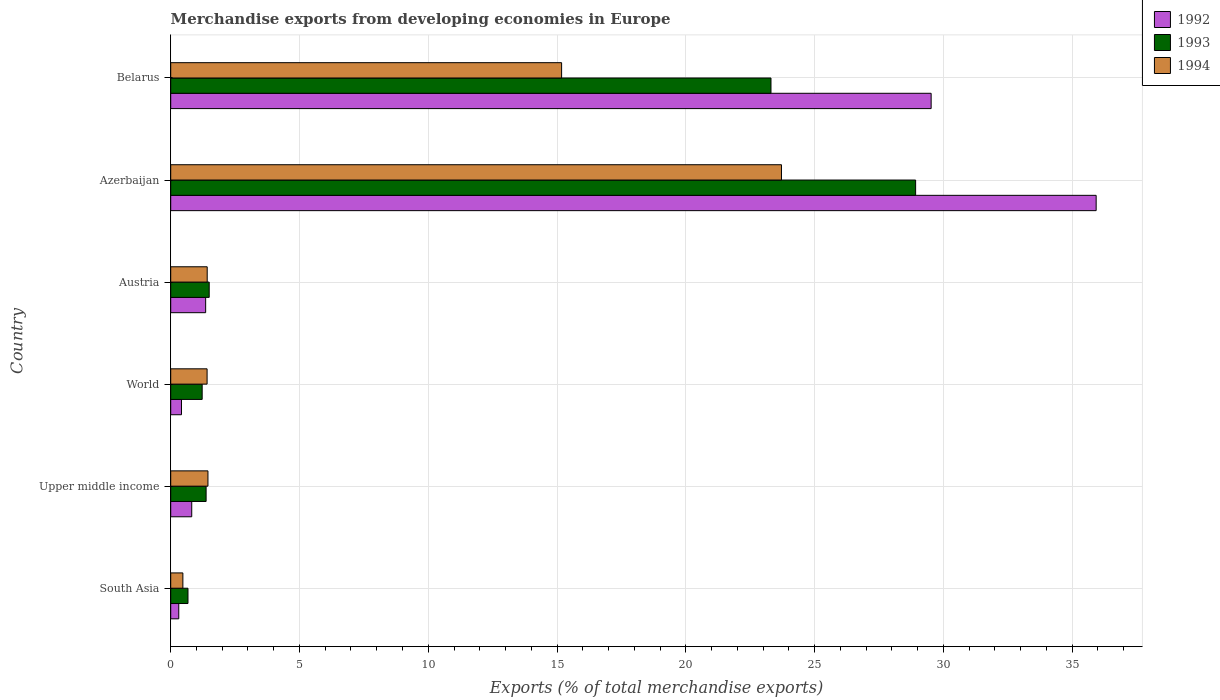How many groups of bars are there?
Keep it short and to the point. 6. Are the number of bars on each tick of the Y-axis equal?
Offer a terse response. Yes. How many bars are there on the 3rd tick from the top?
Offer a very short reply. 3. What is the label of the 4th group of bars from the top?
Provide a short and direct response. World. In how many cases, is the number of bars for a given country not equal to the number of legend labels?
Provide a short and direct response. 0. What is the percentage of total merchandise exports in 1994 in World?
Provide a short and direct response. 1.41. Across all countries, what is the maximum percentage of total merchandise exports in 1994?
Ensure brevity in your answer.  23.72. Across all countries, what is the minimum percentage of total merchandise exports in 1993?
Your answer should be compact. 0.67. In which country was the percentage of total merchandise exports in 1992 maximum?
Offer a very short reply. Azerbaijan. What is the total percentage of total merchandise exports in 1992 in the graph?
Your answer should be compact. 68.37. What is the difference between the percentage of total merchandise exports in 1992 in Azerbaijan and that in Upper middle income?
Provide a short and direct response. 35.12. What is the difference between the percentage of total merchandise exports in 1994 in South Asia and the percentage of total merchandise exports in 1992 in World?
Your answer should be compact. 0.05. What is the average percentage of total merchandise exports in 1993 per country?
Ensure brevity in your answer.  9.5. What is the difference between the percentage of total merchandise exports in 1992 and percentage of total merchandise exports in 1994 in Upper middle income?
Keep it short and to the point. -0.63. In how many countries, is the percentage of total merchandise exports in 1992 greater than 6 %?
Offer a very short reply. 2. What is the ratio of the percentage of total merchandise exports in 1993 in Austria to that in South Asia?
Offer a very short reply. 2.23. Is the percentage of total merchandise exports in 1992 in Azerbaijan less than that in South Asia?
Your answer should be compact. No. What is the difference between the highest and the second highest percentage of total merchandise exports in 1994?
Keep it short and to the point. 8.54. What is the difference between the highest and the lowest percentage of total merchandise exports in 1992?
Provide a short and direct response. 35.62. In how many countries, is the percentage of total merchandise exports in 1993 greater than the average percentage of total merchandise exports in 1993 taken over all countries?
Your answer should be compact. 2. What does the 2nd bar from the top in South Asia represents?
Your answer should be compact. 1993. What does the 1st bar from the bottom in South Asia represents?
Provide a short and direct response. 1992. Is it the case that in every country, the sum of the percentage of total merchandise exports in 1993 and percentage of total merchandise exports in 1994 is greater than the percentage of total merchandise exports in 1992?
Provide a short and direct response. Yes. Are all the bars in the graph horizontal?
Offer a terse response. Yes. How many countries are there in the graph?
Offer a terse response. 6. Does the graph contain any zero values?
Provide a short and direct response. No. Does the graph contain grids?
Offer a very short reply. Yes. How are the legend labels stacked?
Offer a terse response. Vertical. What is the title of the graph?
Make the answer very short. Merchandise exports from developing economies in Europe. Does "2009" appear as one of the legend labels in the graph?
Your response must be concise. No. What is the label or title of the X-axis?
Provide a succinct answer. Exports (% of total merchandise exports). What is the Exports (% of total merchandise exports) in 1992 in South Asia?
Provide a short and direct response. 0.31. What is the Exports (% of total merchandise exports) of 1993 in South Asia?
Ensure brevity in your answer.  0.67. What is the Exports (% of total merchandise exports) in 1994 in South Asia?
Ensure brevity in your answer.  0.47. What is the Exports (% of total merchandise exports) of 1992 in Upper middle income?
Provide a succinct answer. 0.82. What is the Exports (% of total merchandise exports) of 1993 in Upper middle income?
Offer a terse response. 1.37. What is the Exports (% of total merchandise exports) in 1994 in Upper middle income?
Offer a terse response. 1.45. What is the Exports (% of total merchandise exports) in 1992 in World?
Your response must be concise. 0.42. What is the Exports (% of total merchandise exports) of 1993 in World?
Provide a succinct answer. 1.22. What is the Exports (% of total merchandise exports) in 1994 in World?
Make the answer very short. 1.41. What is the Exports (% of total merchandise exports) of 1992 in Austria?
Provide a short and direct response. 1.36. What is the Exports (% of total merchandise exports) of 1993 in Austria?
Provide a succinct answer. 1.49. What is the Exports (% of total merchandise exports) of 1994 in Austria?
Make the answer very short. 1.42. What is the Exports (% of total merchandise exports) in 1992 in Azerbaijan?
Provide a short and direct response. 35.94. What is the Exports (% of total merchandise exports) of 1993 in Azerbaijan?
Provide a short and direct response. 28.93. What is the Exports (% of total merchandise exports) in 1994 in Azerbaijan?
Offer a very short reply. 23.72. What is the Exports (% of total merchandise exports) of 1992 in Belarus?
Provide a succinct answer. 29.53. What is the Exports (% of total merchandise exports) in 1993 in Belarus?
Your answer should be very brief. 23.31. What is the Exports (% of total merchandise exports) in 1994 in Belarus?
Keep it short and to the point. 15.18. Across all countries, what is the maximum Exports (% of total merchandise exports) of 1992?
Provide a short and direct response. 35.94. Across all countries, what is the maximum Exports (% of total merchandise exports) of 1993?
Provide a succinct answer. 28.93. Across all countries, what is the maximum Exports (% of total merchandise exports) in 1994?
Ensure brevity in your answer.  23.72. Across all countries, what is the minimum Exports (% of total merchandise exports) in 1992?
Provide a short and direct response. 0.31. Across all countries, what is the minimum Exports (% of total merchandise exports) of 1993?
Keep it short and to the point. 0.67. Across all countries, what is the minimum Exports (% of total merchandise exports) in 1994?
Provide a short and direct response. 0.47. What is the total Exports (% of total merchandise exports) in 1992 in the graph?
Your response must be concise. 68.37. What is the total Exports (% of total merchandise exports) in 1993 in the graph?
Ensure brevity in your answer.  57. What is the total Exports (% of total merchandise exports) in 1994 in the graph?
Keep it short and to the point. 43.64. What is the difference between the Exports (% of total merchandise exports) of 1992 in South Asia and that in Upper middle income?
Your answer should be compact. -0.5. What is the difference between the Exports (% of total merchandise exports) in 1993 in South Asia and that in Upper middle income?
Your answer should be compact. -0.7. What is the difference between the Exports (% of total merchandise exports) in 1994 in South Asia and that in Upper middle income?
Keep it short and to the point. -0.97. What is the difference between the Exports (% of total merchandise exports) of 1992 in South Asia and that in World?
Keep it short and to the point. -0.11. What is the difference between the Exports (% of total merchandise exports) in 1993 in South Asia and that in World?
Give a very brief answer. -0.55. What is the difference between the Exports (% of total merchandise exports) in 1994 in South Asia and that in World?
Keep it short and to the point. -0.94. What is the difference between the Exports (% of total merchandise exports) in 1992 in South Asia and that in Austria?
Your answer should be compact. -1.04. What is the difference between the Exports (% of total merchandise exports) in 1993 in South Asia and that in Austria?
Your response must be concise. -0.82. What is the difference between the Exports (% of total merchandise exports) in 1994 in South Asia and that in Austria?
Give a very brief answer. -0.94. What is the difference between the Exports (% of total merchandise exports) in 1992 in South Asia and that in Azerbaijan?
Make the answer very short. -35.62. What is the difference between the Exports (% of total merchandise exports) of 1993 in South Asia and that in Azerbaijan?
Provide a succinct answer. -28.26. What is the difference between the Exports (% of total merchandise exports) of 1994 in South Asia and that in Azerbaijan?
Your answer should be very brief. -23.24. What is the difference between the Exports (% of total merchandise exports) of 1992 in South Asia and that in Belarus?
Your answer should be very brief. -29.21. What is the difference between the Exports (% of total merchandise exports) of 1993 in South Asia and that in Belarus?
Your response must be concise. -22.64. What is the difference between the Exports (% of total merchandise exports) of 1994 in South Asia and that in Belarus?
Your answer should be very brief. -14.71. What is the difference between the Exports (% of total merchandise exports) in 1992 in Upper middle income and that in World?
Your answer should be very brief. 0.4. What is the difference between the Exports (% of total merchandise exports) in 1993 in Upper middle income and that in World?
Give a very brief answer. 0.15. What is the difference between the Exports (% of total merchandise exports) in 1994 in Upper middle income and that in World?
Make the answer very short. 0.03. What is the difference between the Exports (% of total merchandise exports) of 1992 in Upper middle income and that in Austria?
Give a very brief answer. -0.54. What is the difference between the Exports (% of total merchandise exports) of 1993 in Upper middle income and that in Austria?
Make the answer very short. -0.12. What is the difference between the Exports (% of total merchandise exports) of 1994 in Upper middle income and that in Austria?
Make the answer very short. 0.03. What is the difference between the Exports (% of total merchandise exports) of 1992 in Upper middle income and that in Azerbaijan?
Offer a terse response. -35.12. What is the difference between the Exports (% of total merchandise exports) in 1993 in Upper middle income and that in Azerbaijan?
Your answer should be very brief. -27.55. What is the difference between the Exports (% of total merchandise exports) in 1994 in Upper middle income and that in Azerbaijan?
Ensure brevity in your answer.  -22.27. What is the difference between the Exports (% of total merchandise exports) in 1992 in Upper middle income and that in Belarus?
Give a very brief answer. -28.71. What is the difference between the Exports (% of total merchandise exports) of 1993 in Upper middle income and that in Belarus?
Give a very brief answer. -21.93. What is the difference between the Exports (% of total merchandise exports) in 1994 in Upper middle income and that in Belarus?
Provide a succinct answer. -13.73. What is the difference between the Exports (% of total merchandise exports) of 1992 in World and that in Austria?
Provide a succinct answer. -0.94. What is the difference between the Exports (% of total merchandise exports) in 1993 in World and that in Austria?
Give a very brief answer. -0.27. What is the difference between the Exports (% of total merchandise exports) of 1994 in World and that in Austria?
Ensure brevity in your answer.  -0. What is the difference between the Exports (% of total merchandise exports) of 1992 in World and that in Azerbaijan?
Your response must be concise. -35.52. What is the difference between the Exports (% of total merchandise exports) of 1993 in World and that in Azerbaijan?
Offer a very short reply. -27.7. What is the difference between the Exports (% of total merchandise exports) in 1994 in World and that in Azerbaijan?
Provide a succinct answer. -22.3. What is the difference between the Exports (% of total merchandise exports) of 1992 in World and that in Belarus?
Your answer should be very brief. -29.11. What is the difference between the Exports (% of total merchandise exports) of 1993 in World and that in Belarus?
Give a very brief answer. -22.09. What is the difference between the Exports (% of total merchandise exports) of 1994 in World and that in Belarus?
Offer a very short reply. -13.77. What is the difference between the Exports (% of total merchandise exports) of 1992 in Austria and that in Azerbaijan?
Your response must be concise. -34.58. What is the difference between the Exports (% of total merchandise exports) in 1993 in Austria and that in Azerbaijan?
Provide a succinct answer. -27.43. What is the difference between the Exports (% of total merchandise exports) in 1994 in Austria and that in Azerbaijan?
Keep it short and to the point. -22.3. What is the difference between the Exports (% of total merchandise exports) in 1992 in Austria and that in Belarus?
Your response must be concise. -28.17. What is the difference between the Exports (% of total merchandise exports) in 1993 in Austria and that in Belarus?
Make the answer very short. -21.81. What is the difference between the Exports (% of total merchandise exports) in 1994 in Austria and that in Belarus?
Provide a short and direct response. -13.76. What is the difference between the Exports (% of total merchandise exports) of 1992 in Azerbaijan and that in Belarus?
Your answer should be very brief. 6.41. What is the difference between the Exports (% of total merchandise exports) of 1993 in Azerbaijan and that in Belarus?
Make the answer very short. 5.62. What is the difference between the Exports (% of total merchandise exports) in 1994 in Azerbaijan and that in Belarus?
Make the answer very short. 8.54. What is the difference between the Exports (% of total merchandise exports) in 1992 in South Asia and the Exports (% of total merchandise exports) in 1993 in Upper middle income?
Keep it short and to the point. -1.06. What is the difference between the Exports (% of total merchandise exports) in 1992 in South Asia and the Exports (% of total merchandise exports) in 1994 in Upper middle income?
Provide a succinct answer. -1.13. What is the difference between the Exports (% of total merchandise exports) of 1993 in South Asia and the Exports (% of total merchandise exports) of 1994 in Upper middle income?
Provide a succinct answer. -0.78. What is the difference between the Exports (% of total merchandise exports) in 1992 in South Asia and the Exports (% of total merchandise exports) in 1993 in World?
Offer a terse response. -0.91. What is the difference between the Exports (% of total merchandise exports) in 1992 in South Asia and the Exports (% of total merchandise exports) in 1994 in World?
Provide a short and direct response. -1.1. What is the difference between the Exports (% of total merchandise exports) of 1993 in South Asia and the Exports (% of total merchandise exports) of 1994 in World?
Provide a succinct answer. -0.74. What is the difference between the Exports (% of total merchandise exports) in 1992 in South Asia and the Exports (% of total merchandise exports) in 1993 in Austria?
Give a very brief answer. -1.18. What is the difference between the Exports (% of total merchandise exports) in 1992 in South Asia and the Exports (% of total merchandise exports) in 1994 in Austria?
Ensure brevity in your answer.  -1.1. What is the difference between the Exports (% of total merchandise exports) of 1993 in South Asia and the Exports (% of total merchandise exports) of 1994 in Austria?
Offer a very short reply. -0.75. What is the difference between the Exports (% of total merchandise exports) in 1992 in South Asia and the Exports (% of total merchandise exports) in 1993 in Azerbaijan?
Keep it short and to the point. -28.61. What is the difference between the Exports (% of total merchandise exports) of 1992 in South Asia and the Exports (% of total merchandise exports) of 1994 in Azerbaijan?
Your answer should be compact. -23.4. What is the difference between the Exports (% of total merchandise exports) in 1993 in South Asia and the Exports (% of total merchandise exports) in 1994 in Azerbaijan?
Your answer should be very brief. -23.05. What is the difference between the Exports (% of total merchandise exports) of 1992 in South Asia and the Exports (% of total merchandise exports) of 1993 in Belarus?
Offer a terse response. -23. What is the difference between the Exports (% of total merchandise exports) of 1992 in South Asia and the Exports (% of total merchandise exports) of 1994 in Belarus?
Ensure brevity in your answer.  -14.87. What is the difference between the Exports (% of total merchandise exports) in 1993 in South Asia and the Exports (% of total merchandise exports) in 1994 in Belarus?
Make the answer very short. -14.51. What is the difference between the Exports (% of total merchandise exports) of 1992 in Upper middle income and the Exports (% of total merchandise exports) of 1993 in World?
Your response must be concise. -0.41. What is the difference between the Exports (% of total merchandise exports) of 1992 in Upper middle income and the Exports (% of total merchandise exports) of 1994 in World?
Offer a terse response. -0.6. What is the difference between the Exports (% of total merchandise exports) in 1993 in Upper middle income and the Exports (% of total merchandise exports) in 1994 in World?
Offer a terse response. -0.04. What is the difference between the Exports (% of total merchandise exports) in 1992 in Upper middle income and the Exports (% of total merchandise exports) in 1993 in Austria?
Ensure brevity in your answer.  -0.68. What is the difference between the Exports (% of total merchandise exports) of 1992 in Upper middle income and the Exports (% of total merchandise exports) of 1994 in Austria?
Ensure brevity in your answer.  -0.6. What is the difference between the Exports (% of total merchandise exports) of 1993 in Upper middle income and the Exports (% of total merchandise exports) of 1994 in Austria?
Provide a short and direct response. -0.04. What is the difference between the Exports (% of total merchandise exports) of 1992 in Upper middle income and the Exports (% of total merchandise exports) of 1993 in Azerbaijan?
Offer a very short reply. -28.11. What is the difference between the Exports (% of total merchandise exports) of 1992 in Upper middle income and the Exports (% of total merchandise exports) of 1994 in Azerbaijan?
Your response must be concise. -22.9. What is the difference between the Exports (% of total merchandise exports) of 1993 in Upper middle income and the Exports (% of total merchandise exports) of 1994 in Azerbaijan?
Ensure brevity in your answer.  -22.34. What is the difference between the Exports (% of total merchandise exports) of 1992 in Upper middle income and the Exports (% of total merchandise exports) of 1993 in Belarus?
Give a very brief answer. -22.49. What is the difference between the Exports (% of total merchandise exports) in 1992 in Upper middle income and the Exports (% of total merchandise exports) in 1994 in Belarus?
Keep it short and to the point. -14.36. What is the difference between the Exports (% of total merchandise exports) of 1993 in Upper middle income and the Exports (% of total merchandise exports) of 1994 in Belarus?
Your answer should be compact. -13.8. What is the difference between the Exports (% of total merchandise exports) of 1992 in World and the Exports (% of total merchandise exports) of 1993 in Austria?
Your answer should be very brief. -1.08. What is the difference between the Exports (% of total merchandise exports) in 1992 in World and the Exports (% of total merchandise exports) in 1994 in Austria?
Offer a very short reply. -1. What is the difference between the Exports (% of total merchandise exports) of 1993 in World and the Exports (% of total merchandise exports) of 1994 in Austria?
Give a very brief answer. -0.2. What is the difference between the Exports (% of total merchandise exports) in 1992 in World and the Exports (% of total merchandise exports) in 1993 in Azerbaijan?
Keep it short and to the point. -28.51. What is the difference between the Exports (% of total merchandise exports) in 1992 in World and the Exports (% of total merchandise exports) in 1994 in Azerbaijan?
Offer a very short reply. -23.3. What is the difference between the Exports (% of total merchandise exports) in 1993 in World and the Exports (% of total merchandise exports) in 1994 in Azerbaijan?
Make the answer very short. -22.49. What is the difference between the Exports (% of total merchandise exports) of 1992 in World and the Exports (% of total merchandise exports) of 1993 in Belarus?
Provide a short and direct response. -22.89. What is the difference between the Exports (% of total merchandise exports) of 1992 in World and the Exports (% of total merchandise exports) of 1994 in Belarus?
Give a very brief answer. -14.76. What is the difference between the Exports (% of total merchandise exports) of 1993 in World and the Exports (% of total merchandise exports) of 1994 in Belarus?
Offer a terse response. -13.96. What is the difference between the Exports (% of total merchandise exports) in 1992 in Austria and the Exports (% of total merchandise exports) in 1993 in Azerbaijan?
Your answer should be compact. -27.57. What is the difference between the Exports (% of total merchandise exports) of 1992 in Austria and the Exports (% of total merchandise exports) of 1994 in Azerbaijan?
Your response must be concise. -22.36. What is the difference between the Exports (% of total merchandise exports) of 1993 in Austria and the Exports (% of total merchandise exports) of 1994 in Azerbaijan?
Your answer should be compact. -22.22. What is the difference between the Exports (% of total merchandise exports) in 1992 in Austria and the Exports (% of total merchandise exports) in 1993 in Belarus?
Keep it short and to the point. -21.95. What is the difference between the Exports (% of total merchandise exports) in 1992 in Austria and the Exports (% of total merchandise exports) in 1994 in Belarus?
Your answer should be very brief. -13.82. What is the difference between the Exports (% of total merchandise exports) of 1993 in Austria and the Exports (% of total merchandise exports) of 1994 in Belarus?
Provide a succinct answer. -13.68. What is the difference between the Exports (% of total merchandise exports) of 1992 in Azerbaijan and the Exports (% of total merchandise exports) of 1993 in Belarus?
Give a very brief answer. 12.63. What is the difference between the Exports (% of total merchandise exports) in 1992 in Azerbaijan and the Exports (% of total merchandise exports) in 1994 in Belarus?
Your answer should be compact. 20.76. What is the difference between the Exports (% of total merchandise exports) in 1993 in Azerbaijan and the Exports (% of total merchandise exports) in 1994 in Belarus?
Provide a short and direct response. 13.75. What is the average Exports (% of total merchandise exports) of 1992 per country?
Provide a succinct answer. 11.39. What is the average Exports (% of total merchandise exports) in 1993 per country?
Provide a succinct answer. 9.5. What is the average Exports (% of total merchandise exports) of 1994 per country?
Your answer should be very brief. 7.27. What is the difference between the Exports (% of total merchandise exports) of 1992 and Exports (% of total merchandise exports) of 1993 in South Asia?
Your answer should be very brief. -0.36. What is the difference between the Exports (% of total merchandise exports) in 1992 and Exports (% of total merchandise exports) in 1994 in South Asia?
Provide a short and direct response. -0.16. What is the difference between the Exports (% of total merchandise exports) of 1993 and Exports (% of total merchandise exports) of 1994 in South Asia?
Ensure brevity in your answer.  0.2. What is the difference between the Exports (% of total merchandise exports) of 1992 and Exports (% of total merchandise exports) of 1993 in Upper middle income?
Your answer should be compact. -0.56. What is the difference between the Exports (% of total merchandise exports) of 1992 and Exports (% of total merchandise exports) of 1994 in Upper middle income?
Offer a very short reply. -0.63. What is the difference between the Exports (% of total merchandise exports) of 1993 and Exports (% of total merchandise exports) of 1994 in Upper middle income?
Your answer should be compact. -0.07. What is the difference between the Exports (% of total merchandise exports) in 1992 and Exports (% of total merchandise exports) in 1993 in World?
Ensure brevity in your answer.  -0.8. What is the difference between the Exports (% of total merchandise exports) in 1992 and Exports (% of total merchandise exports) in 1994 in World?
Your answer should be compact. -0.99. What is the difference between the Exports (% of total merchandise exports) of 1993 and Exports (% of total merchandise exports) of 1994 in World?
Give a very brief answer. -0.19. What is the difference between the Exports (% of total merchandise exports) in 1992 and Exports (% of total merchandise exports) in 1993 in Austria?
Keep it short and to the point. -0.14. What is the difference between the Exports (% of total merchandise exports) in 1992 and Exports (% of total merchandise exports) in 1994 in Austria?
Make the answer very short. -0.06. What is the difference between the Exports (% of total merchandise exports) of 1993 and Exports (% of total merchandise exports) of 1994 in Austria?
Ensure brevity in your answer.  0.08. What is the difference between the Exports (% of total merchandise exports) of 1992 and Exports (% of total merchandise exports) of 1993 in Azerbaijan?
Your answer should be very brief. 7.01. What is the difference between the Exports (% of total merchandise exports) in 1992 and Exports (% of total merchandise exports) in 1994 in Azerbaijan?
Your answer should be compact. 12.22. What is the difference between the Exports (% of total merchandise exports) in 1993 and Exports (% of total merchandise exports) in 1994 in Azerbaijan?
Offer a terse response. 5.21. What is the difference between the Exports (% of total merchandise exports) in 1992 and Exports (% of total merchandise exports) in 1993 in Belarus?
Keep it short and to the point. 6.22. What is the difference between the Exports (% of total merchandise exports) of 1992 and Exports (% of total merchandise exports) of 1994 in Belarus?
Offer a very short reply. 14.35. What is the difference between the Exports (% of total merchandise exports) in 1993 and Exports (% of total merchandise exports) in 1994 in Belarus?
Provide a short and direct response. 8.13. What is the ratio of the Exports (% of total merchandise exports) of 1992 in South Asia to that in Upper middle income?
Offer a very short reply. 0.38. What is the ratio of the Exports (% of total merchandise exports) in 1993 in South Asia to that in Upper middle income?
Your response must be concise. 0.49. What is the ratio of the Exports (% of total merchandise exports) in 1994 in South Asia to that in Upper middle income?
Your answer should be very brief. 0.33. What is the ratio of the Exports (% of total merchandise exports) in 1992 in South Asia to that in World?
Give a very brief answer. 0.75. What is the ratio of the Exports (% of total merchandise exports) of 1993 in South Asia to that in World?
Provide a short and direct response. 0.55. What is the ratio of the Exports (% of total merchandise exports) in 1994 in South Asia to that in World?
Offer a very short reply. 0.33. What is the ratio of the Exports (% of total merchandise exports) of 1992 in South Asia to that in Austria?
Offer a very short reply. 0.23. What is the ratio of the Exports (% of total merchandise exports) of 1993 in South Asia to that in Austria?
Your answer should be very brief. 0.45. What is the ratio of the Exports (% of total merchandise exports) in 1994 in South Asia to that in Austria?
Give a very brief answer. 0.33. What is the ratio of the Exports (% of total merchandise exports) in 1992 in South Asia to that in Azerbaijan?
Make the answer very short. 0.01. What is the ratio of the Exports (% of total merchandise exports) of 1993 in South Asia to that in Azerbaijan?
Offer a terse response. 0.02. What is the ratio of the Exports (% of total merchandise exports) in 1994 in South Asia to that in Azerbaijan?
Your response must be concise. 0.02. What is the ratio of the Exports (% of total merchandise exports) in 1992 in South Asia to that in Belarus?
Offer a terse response. 0.01. What is the ratio of the Exports (% of total merchandise exports) in 1993 in South Asia to that in Belarus?
Provide a short and direct response. 0.03. What is the ratio of the Exports (% of total merchandise exports) of 1994 in South Asia to that in Belarus?
Ensure brevity in your answer.  0.03. What is the ratio of the Exports (% of total merchandise exports) in 1992 in Upper middle income to that in World?
Make the answer very short. 1.95. What is the ratio of the Exports (% of total merchandise exports) of 1993 in Upper middle income to that in World?
Provide a succinct answer. 1.13. What is the ratio of the Exports (% of total merchandise exports) in 1994 in Upper middle income to that in World?
Your answer should be very brief. 1.02. What is the ratio of the Exports (% of total merchandise exports) in 1992 in Upper middle income to that in Austria?
Your response must be concise. 0.6. What is the ratio of the Exports (% of total merchandise exports) in 1993 in Upper middle income to that in Austria?
Provide a succinct answer. 0.92. What is the ratio of the Exports (% of total merchandise exports) of 1994 in Upper middle income to that in Austria?
Ensure brevity in your answer.  1.02. What is the ratio of the Exports (% of total merchandise exports) in 1992 in Upper middle income to that in Azerbaijan?
Your answer should be very brief. 0.02. What is the ratio of the Exports (% of total merchandise exports) of 1993 in Upper middle income to that in Azerbaijan?
Keep it short and to the point. 0.05. What is the ratio of the Exports (% of total merchandise exports) in 1994 in Upper middle income to that in Azerbaijan?
Offer a very short reply. 0.06. What is the ratio of the Exports (% of total merchandise exports) of 1992 in Upper middle income to that in Belarus?
Keep it short and to the point. 0.03. What is the ratio of the Exports (% of total merchandise exports) in 1993 in Upper middle income to that in Belarus?
Provide a short and direct response. 0.06. What is the ratio of the Exports (% of total merchandise exports) of 1994 in Upper middle income to that in Belarus?
Your answer should be compact. 0.1. What is the ratio of the Exports (% of total merchandise exports) of 1992 in World to that in Austria?
Your response must be concise. 0.31. What is the ratio of the Exports (% of total merchandise exports) of 1993 in World to that in Austria?
Offer a very short reply. 0.82. What is the ratio of the Exports (% of total merchandise exports) in 1994 in World to that in Austria?
Your response must be concise. 1. What is the ratio of the Exports (% of total merchandise exports) of 1992 in World to that in Azerbaijan?
Offer a very short reply. 0.01. What is the ratio of the Exports (% of total merchandise exports) in 1993 in World to that in Azerbaijan?
Offer a terse response. 0.04. What is the ratio of the Exports (% of total merchandise exports) of 1994 in World to that in Azerbaijan?
Your answer should be compact. 0.06. What is the ratio of the Exports (% of total merchandise exports) of 1992 in World to that in Belarus?
Your answer should be compact. 0.01. What is the ratio of the Exports (% of total merchandise exports) in 1993 in World to that in Belarus?
Offer a very short reply. 0.05. What is the ratio of the Exports (% of total merchandise exports) of 1994 in World to that in Belarus?
Your answer should be very brief. 0.09. What is the ratio of the Exports (% of total merchandise exports) in 1992 in Austria to that in Azerbaijan?
Offer a very short reply. 0.04. What is the ratio of the Exports (% of total merchandise exports) of 1993 in Austria to that in Azerbaijan?
Your answer should be very brief. 0.05. What is the ratio of the Exports (% of total merchandise exports) in 1994 in Austria to that in Azerbaijan?
Your response must be concise. 0.06. What is the ratio of the Exports (% of total merchandise exports) in 1992 in Austria to that in Belarus?
Ensure brevity in your answer.  0.05. What is the ratio of the Exports (% of total merchandise exports) in 1993 in Austria to that in Belarus?
Offer a terse response. 0.06. What is the ratio of the Exports (% of total merchandise exports) of 1994 in Austria to that in Belarus?
Offer a terse response. 0.09. What is the ratio of the Exports (% of total merchandise exports) of 1992 in Azerbaijan to that in Belarus?
Your answer should be very brief. 1.22. What is the ratio of the Exports (% of total merchandise exports) of 1993 in Azerbaijan to that in Belarus?
Provide a short and direct response. 1.24. What is the ratio of the Exports (% of total merchandise exports) of 1994 in Azerbaijan to that in Belarus?
Keep it short and to the point. 1.56. What is the difference between the highest and the second highest Exports (% of total merchandise exports) of 1992?
Your response must be concise. 6.41. What is the difference between the highest and the second highest Exports (% of total merchandise exports) in 1993?
Ensure brevity in your answer.  5.62. What is the difference between the highest and the second highest Exports (% of total merchandise exports) in 1994?
Offer a very short reply. 8.54. What is the difference between the highest and the lowest Exports (% of total merchandise exports) of 1992?
Make the answer very short. 35.62. What is the difference between the highest and the lowest Exports (% of total merchandise exports) of 1993?
Give a very brief answer. 28.26. What is the difference between the highest and the lowest Exports (% of total merchandise exports) in 1994?
Offer a terse response. 23.24. 